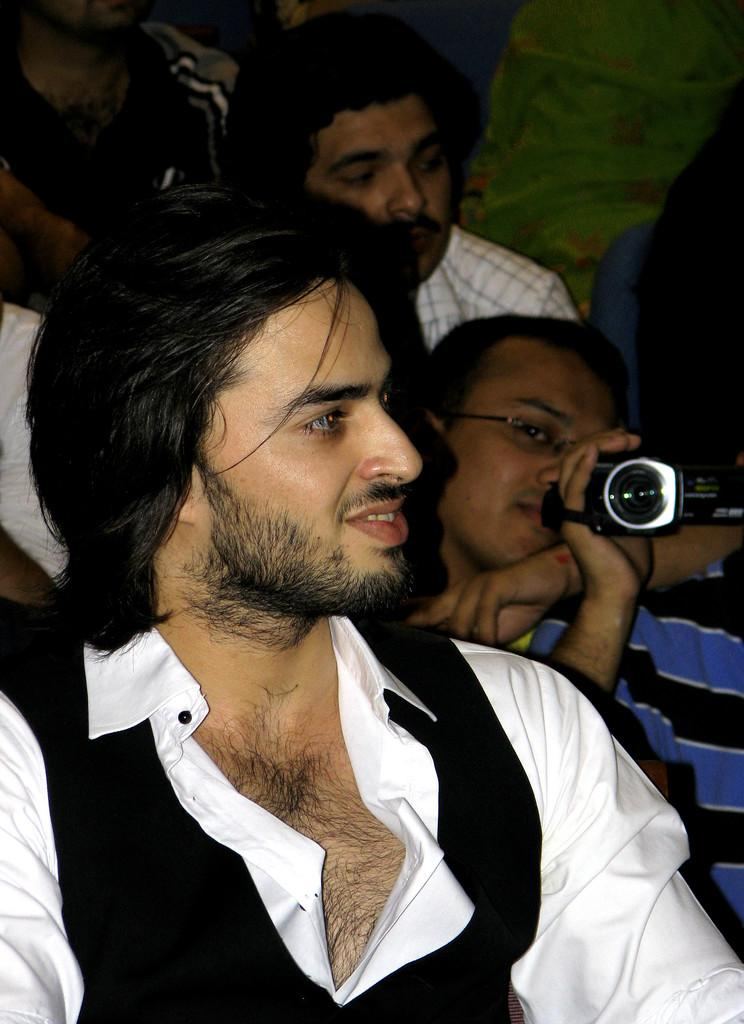How many people are in the image? There is a group of people in the image, but the exact number is not specified. What is one person in the group doing? One man is capturing the scene with his camera. What type of roof can be seen on the building in the background of the image? There is no building or roof visible in the image; it only shows a group of people and a man with a camera. 